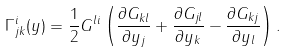<formula> <loc_0><loc_0><loc_500><loc_500>\Gamma ^ { i } _ { j k } ( y ) = \frac { 1 } { 2 } G ^ { l i } \left ( \frac { \partial G _ { k l } } { \partial y _ { j } } + \frac { \partial G _ { j l } } { \partial y _ { k } } - \frac { \partial G _ { k j } } { \partial y _ { l } } \right ) .</formula> 